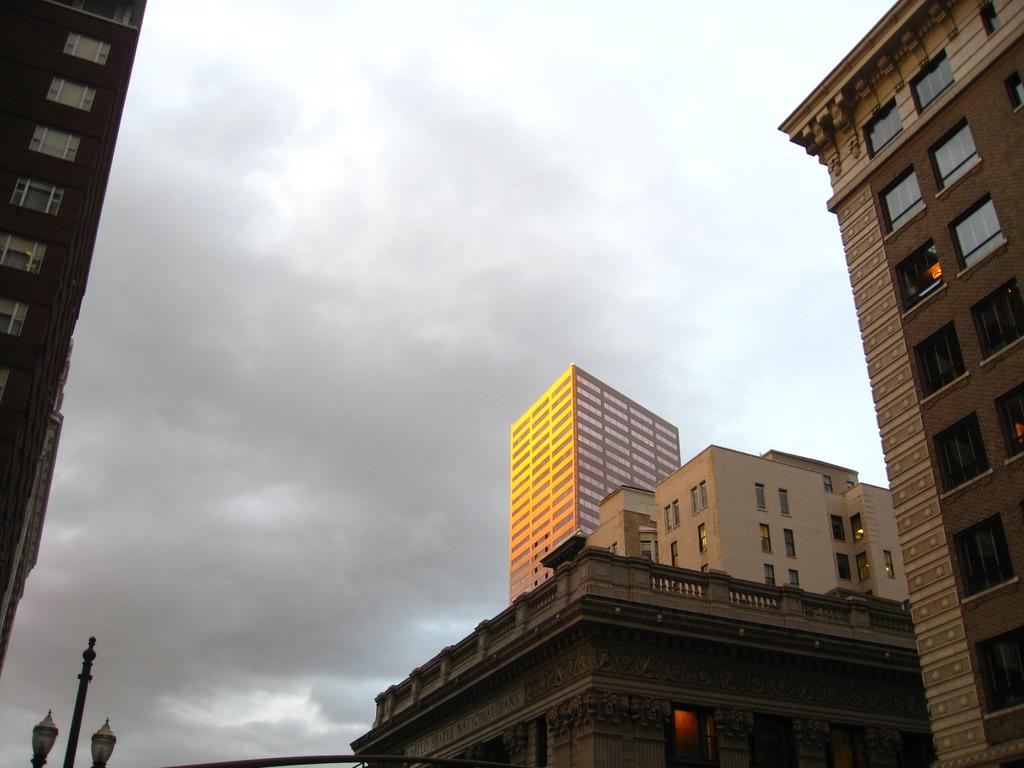What type of structures can be seen in the image? There are buildings in the image. What architectural feature can be seen on the buildings? There are windows visible in the image. What type of street infrastructure is present in the image? There are light poles in the image. What is visible in the background of the image? The sky is visible in the image. Can you tell me how many coaches are parked near the buildings in the image? There are no coaches present in the image. What type of knot is being used to secure the light poles in the image? There is no knot visible in the image, as the light poles are likely secured with bolts or other fasteners. 